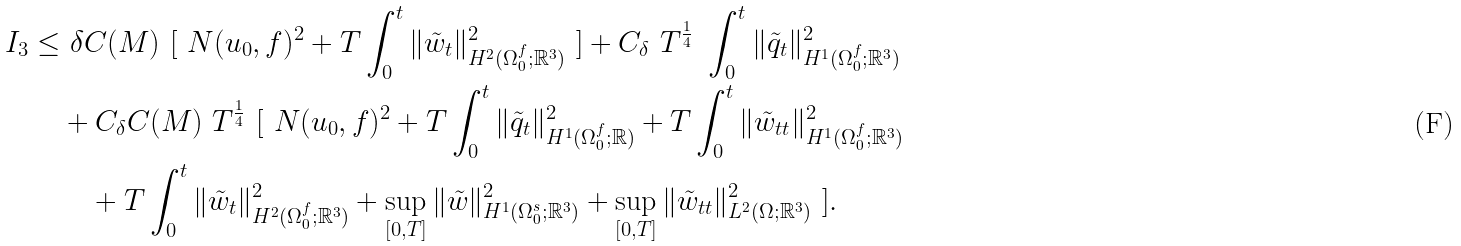Convert formula to latex. <formula><loc_0><loc_0><loc_500><loc_500>I _ { 3 } \leq & \ \delta C ( M ) \ [ \ N ( u _ { 0 } , f ) ^ { 2 } + T \int _ { 0 } ^ { t } \| \tilde { w } _ { t } \| ^ { 2 } _ { H ^ { 2 } ( \Omega _ { 0 } ^ { f } ; { \mathbb { R } } ^ { 3 } ) } \ ] + C _ { \delta } \ T ^ { \frac { 1 } { 4 } } \ \int _ { 0 } ^ { t } \| \tilde { q } _ { t } \| ^ { 2 } _ { H ^ { 1 } ( \Omega _ { 0 } ^ { f } ; { \mathbb { R } } ^ { 3 } ) } \\ & + C _ { \delta } C ( M ) \ T ^ { \frac { 1 } { 4 } } \ [ \ N ( u _ { 0 } , f ) ^ { 2 } + T \int _ { 0 } ^ { t } \| \tilde { q } _ { t } \| ^ { 2 } _ { H ^ { 1 } ( \Omega _ { 0 } ^ { f } ; { \mathbb { R } } ) } + T \int _ { 0 } ^ { t } \| \tilde { w } _ { t t } \| ^ { 2 } _ { H ^ { 1 } ( \Omega _ { 0 } ^ { f } ; { \mathbb { R } } ^ { 3 } ) } \\ & \quad + T \int _ { 0 } ^ { t } \| \tilde { w } _ { t } \| ^ { 2 } _ { H ^ { 2 } ( \Omega _ { 0 } ^ { f } ; { \mathbb { R } } ^ { 3 } ) } + \sup _ { [ 0 , T ] } \| \tilde { w } \| ^ { 2 } _ { H ^ { 1 } ( \Omega _ { 0 } ^ { s } ; { \mathbb { R } } ^ { 3 } ) } + \sup _ { [ 0 , T ] } \| \tilde { w } _ { t t } \| ^ { 2 } _ { L ^ { 2 } ( \Omega ; { \mathbb { R } } ^ { 3 } ) } \ ] .</formula> 